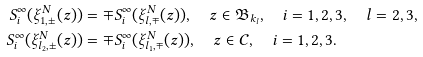<formula> <loc_0><loc_0><loc_500><loc_500>S ^ { \infty } _ { i } ( \xi _ { 1 , \pm } ^ { N } ( z ) ) & = \mp S ^ { \infty } _ { i } ( \xi _ { l , \mp } ^ { N } ( z ) ) , \quad z \in \mathfrak { B } _ { k _ { l } } , \quad i = 1 , 2 , 3 , \quad l = 2 , 3 , \\ S ^ { \infty } _ { i } ( \xi _ { l _ { 2 } , { \pm } } ^ { N } ( z ) ) & = \mp S ^ { \infty } _ { i } ( \xi _ { l _ { 1 } , \mp } ^ { N } ( z ) ) , \quad z \in \mathcal { C } , \quad i = 1 , 2 , 3 .</formula> 